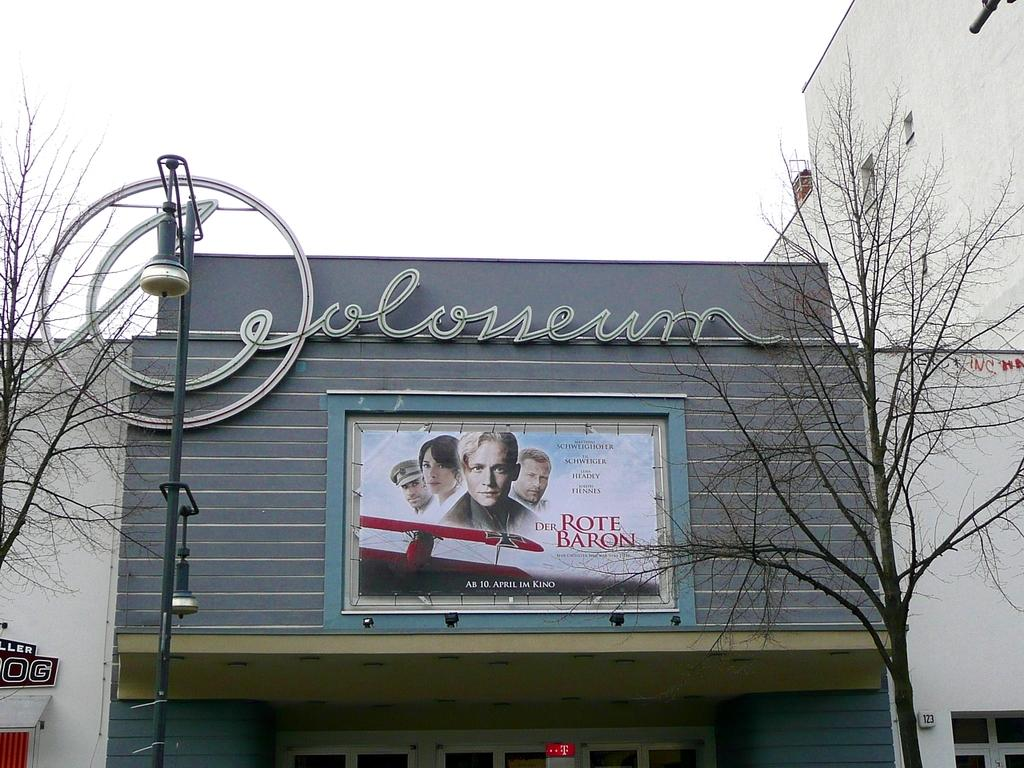<image>
Relay a brief, clear account of the picture shown. a movie advertisement for the movie Der Rothe Baron is on a building 